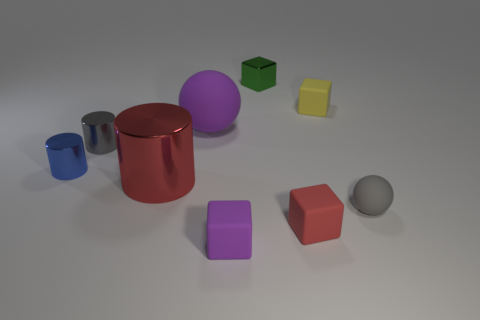What is the color of the large shiny cylinder?
Your response must be concise. Red. There is a large red cylinder that is behind the small rubber ball; what number of red rubber blocks are left of it?
Provide a succinct answer. 0. How big is the metallic object that is both right of the gray shiny object and in front of the tiny green metal block?
Keep it short and to the point. Large. What is the material of the purple thing behind the small gray matte thing?
Provide a short and direct response. Rubber. Are there any other matte objects that have the same shape as the big rubber thing?
Provide a short and direct response. Yes. What number of yellow rubber things are the same shape as the small purple rubber object?
Your answer should be compact. 1. There is a sphere that is on the right side of the metal block; is it the same size as the rubber ball behind the small gray metallic cylinder?
Provide a short and direct response. No. There is a purple thing in front of the matte sphere that is behind the small blue metallic cylinder; what is its shape?
Ensure brevity in your answer.  Cube. Are there an equal number of big red shiny things in front of the gray sphere and purple metal things?
Ensure brevity in your answer.  Yes. There is a purple object behind the sphere in front of the thing that is on the left side of the tiny gray metal thing; what is it made of?
Ensure brevity in your answer.  Rubber. 